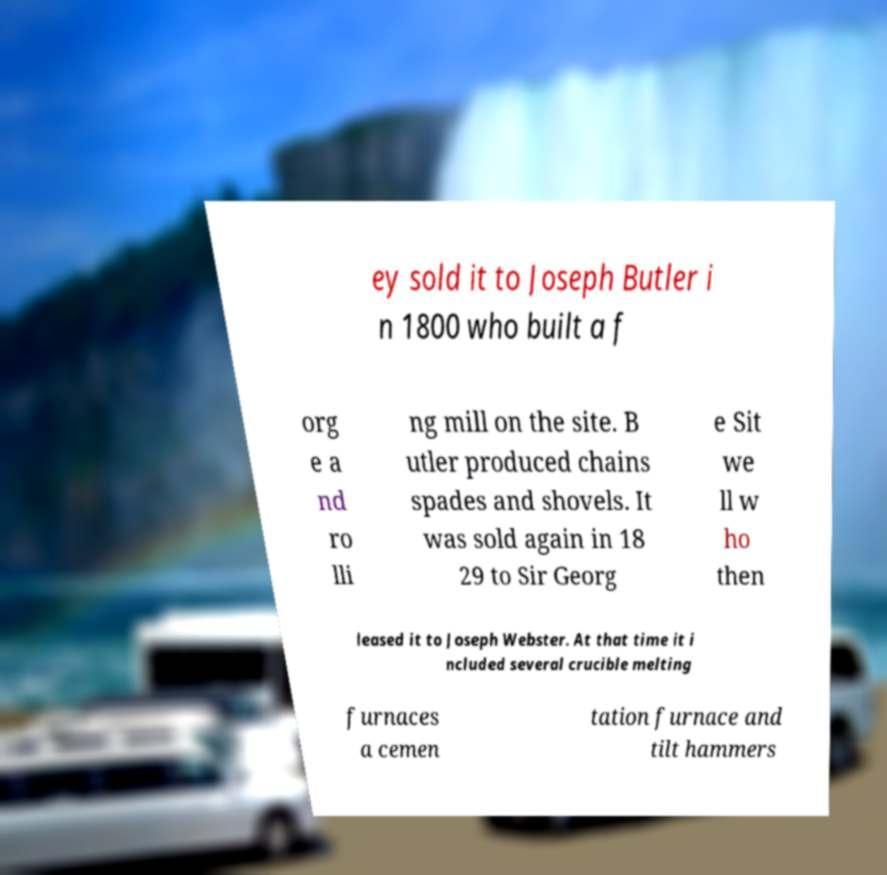For documentation purposes, I need the text within this image transcribed. Could you provide that? ey sold it to Joseph Butler i n 1800 who built a f org e a nd ro lli ng mill on the site. B utler produced chains spades and shovels. It was sold again in 18 29 to Sir Georg e Sit we ll w ho then leased it to Joseph Webster. At that time it i ncluded several crucible melting furnaces a cemen tation furnace and tilt hammers 